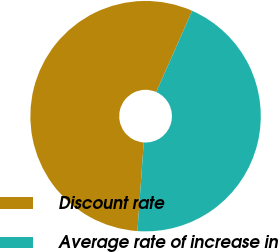Convert chart. <chart><loc_0><loc_0><loc_500><loc_500><pie_chart><fcel>Discount rate<fcel>Average rate of increase in<nl><fcel>55.5%<fcel>44.5%<nl></chart> 